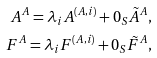Convert formula to latex. <formula><loc_0><loc_0><loc_500><loc_500>A ^ { A } = \lambda _ { i } A ^ { \left ( A , i \right ) } + 0 _ { S } \tilde { A } ^ { A } , \\ F ^ { A } = \lambda _ { i } F ^ { \left ( A , i \right ) } + 0 _ { S } \tilde { F } ^ { A } ,</formula> 